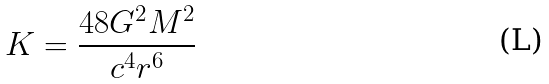Convert formula to latex. <formula><loc_0><loc_0><loc_500><loc_500>K = \frac { 4 8 G ^ { 2 } M ^ { 2 } } { c ^ { 4 } r ^ { 6 } }</formula> 